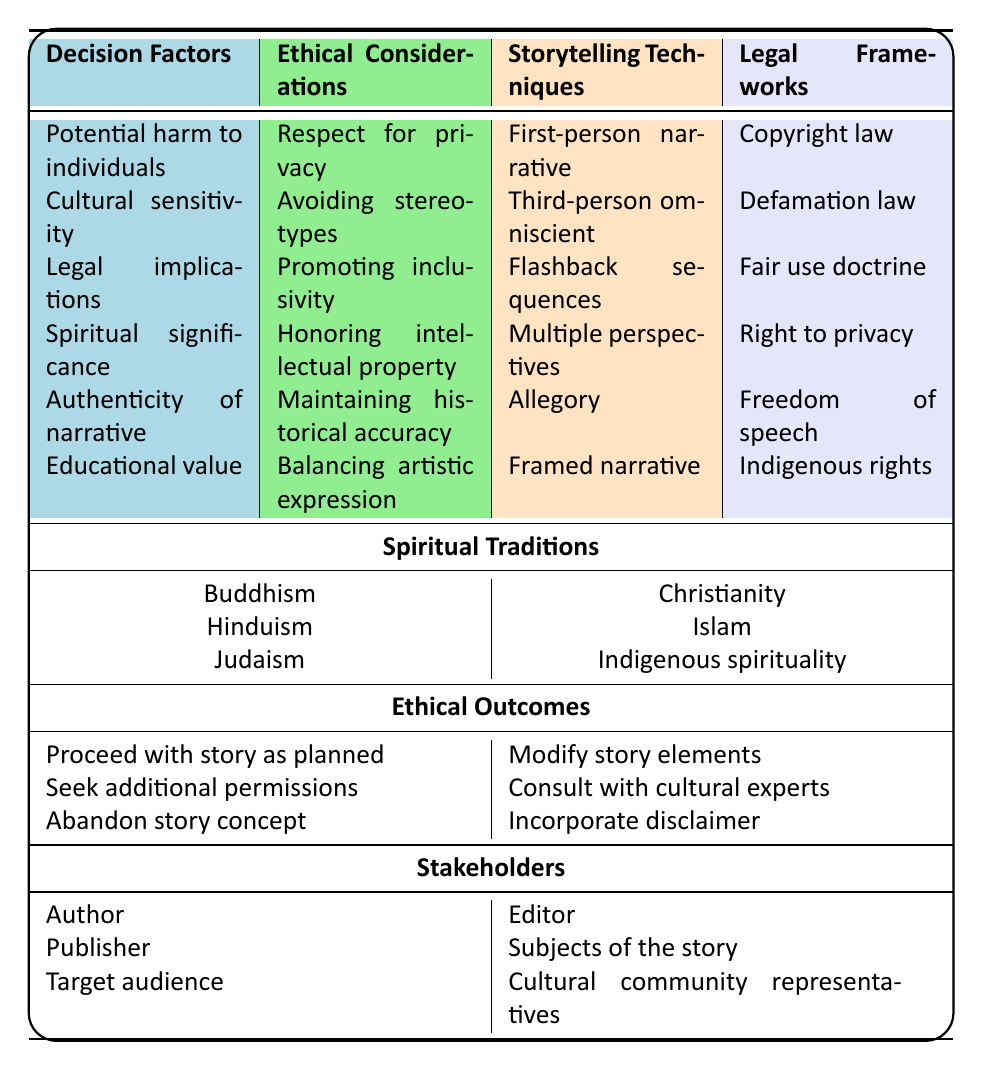What are the potential harms associated with storytelling? The table lists "Potential harm to individuals" as a decision factor, which indicates that storytellers need to consider how their narratives might harm individuals involved. Therefore, the potential harms relate to the negative impact on individuals, such as emotional distress, misrepresentation, or privacy violations.
Answer: Potential harm to individuals Which ethical consideration is related to avoiding stereotypes? The table connects the ethical consideration "Avoiding stereotypes" to the decision factor "Cultural sensitivity." This suggests that when storytellers are sensitive to different cultures, they should actively work to avoid reinforcing negative stereotypes within their narratives.
Answer: Avoiding stereotypes How many storytelling techniques are listed in the table? The table contains six storytelling techniques: First-person narrative, Third-person omniscient, Flashback sequences, Multiple perspectives, Allegory, and Framed narrative. Thus, the total count is six.
Answer: Six If a storyteller wants to honor intellectual property, which ethical consideration can they refer to? The ethical consideration of "Honoring intellectual property" directly relates to the decision factor "Spiritual significance." Thus, a storyteller focused on honoring these rights can refer to this specific consideration for guidance.
Answer: Honoring intellectual property Is the "Freedom of speech" a legal framework mentioned in the table? Yes, the table includes "Freedom of speech" as one of the legal frameworks relevant to storytelling. This indicates that storytellers must navigate their creative expression while being aware of their legal rights.
Answer: Yes What might a storyteller decide if they need to modify story elements? According to the ethical outcomes listed, if a storyteller decides to modify story elements, they might follow the outcome labeled "Modify story elements." This means they would actively change specific parts of their narrative to address ethical considerations or feedback.
Answer: Modify story elements What is the relationship between "Educational value" and the ethical outcome of seeking additional permissions? The decision factor "Educational value" does not directly link to seeking additional permissions based on the table's data. Instead, seeking additional permissions relates to respecting individuals' rights and cultural sensitivities, which may be connected to both education and storytelling content. Thus, it may not have a straightforward relationship but could be seen as necessary depending on educational contexts.
Answer: No direct relationship Considering the spiritual traditions listed, which one is associated with indigenous rights? The table lists "Indigenous rights" under the legal frameworks section, indicating that it is likely associated with Indigenous spirituality mentioned among the spiritual traditions. This implies that storytellers must consider these rights when their narratives involve Indigenous themes or perspectives.
Answer: Indigenous spirituality What stakeholders are impacted if a story concept is abandoned? If a story concept is abandoned, the stakeholders impacted would include the Author, Editor, Publisher, Subjects of the story, Target audience, and Cultural community representatives. Abandoning a concept can affect all parties involved in its development and reception, resulting in potential loss of effort and resources.
Answer: All stakeholders 